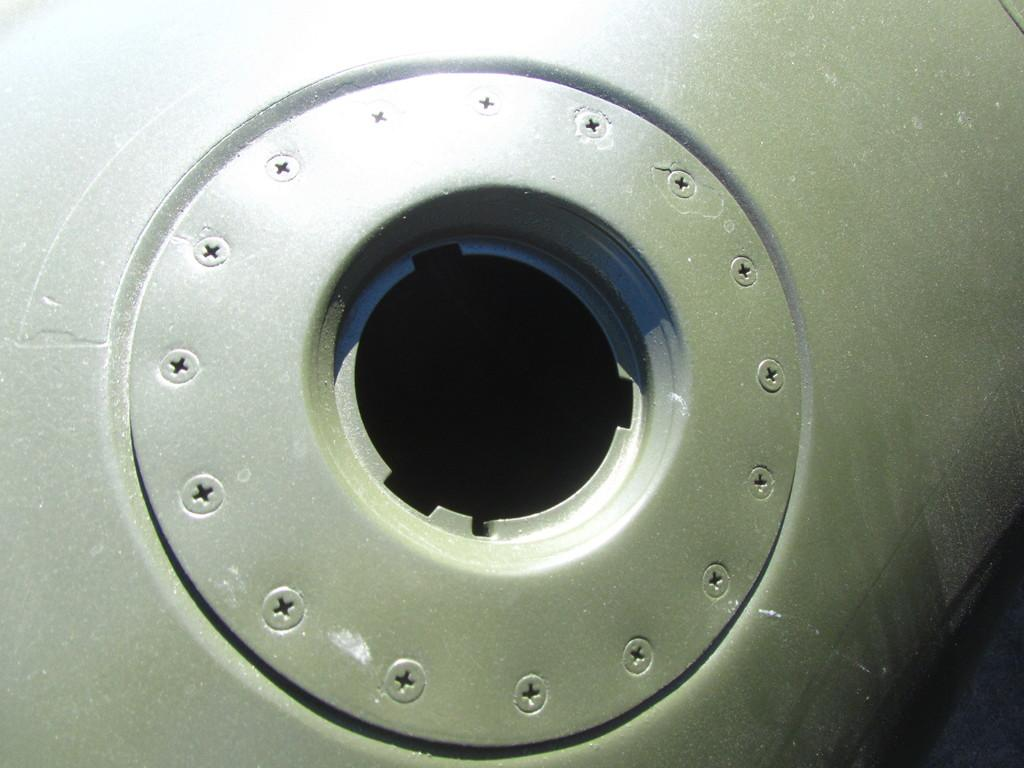What type of object is the main subject of the image? There is a metal tank in the image. What type of smoke can be seen coming from the dime in the bedroom in the image? There is no smoke, dime, or bedroom present in the image; it only features a metal tank. 